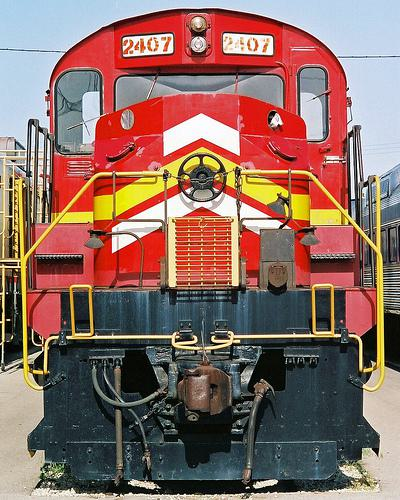Imagine this train in action. What kind of journey could it be on? Visualizing this locomotive in motion, I can imagine it pulling a long line of freight cars across vast landscapes. Its journey might take it through rural countrysides, bustling industrial areas, and into the heart of cities as it transports goods essential for commerce and industry. 